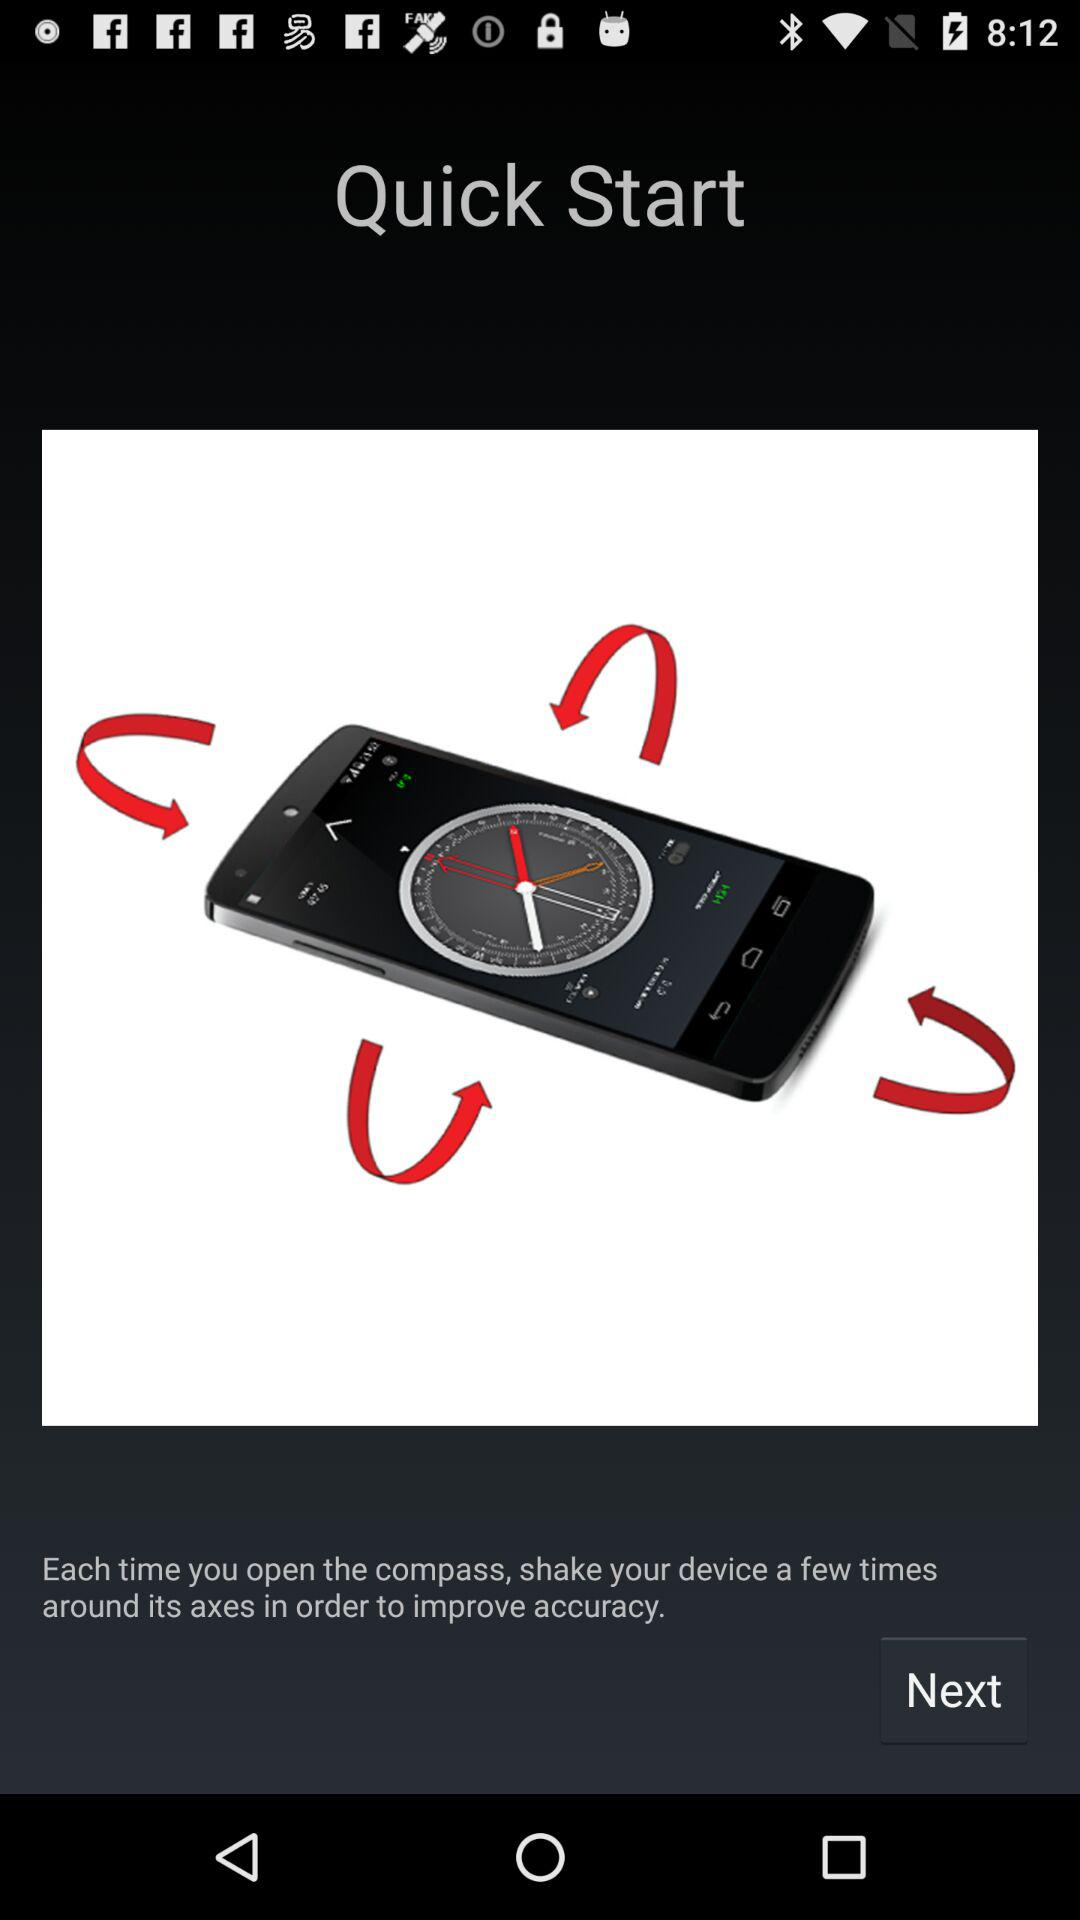What is a Quick Start?
When the provided information is insufficient, respond with <no answer>. <no answer> 